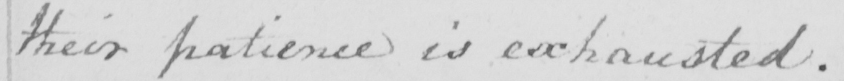Can you read and transcribe this handwriting? their patience is exhausted . 